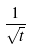Convert formula to latex. <formula><loc_0><loc_0><loc_500><loc_500>\frac { 1 } { \sqrt { t } }</formula> 